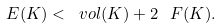<formula> <loc_0><loc_0><loc_500><loc_500>\L E ( K ) < \ v o l ( K ) + 2 \, \ F ( K ) .</formula> 